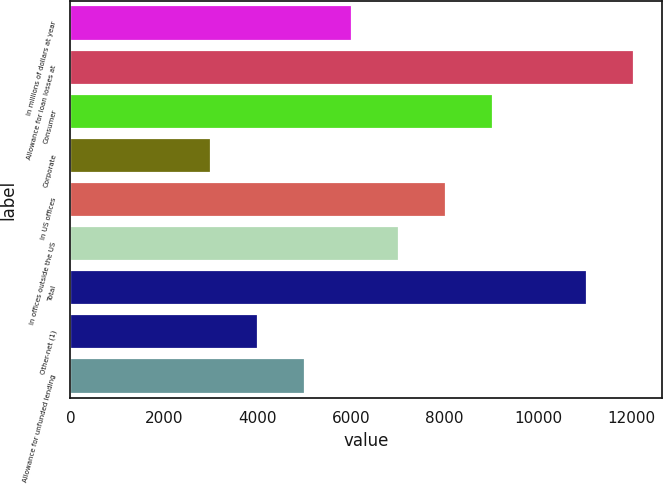<chart> <loc_0><loc_0><loc_500><loc_500><bar_chart><fcel>In millions of dollars at year<fcel>Allowance for loan losses at<fcel>Consumer<fcel>Corporate<fcel>In US offices<fcel>In offices outside the US<fcel>Total<fcel>Other-net (1)<fcel>Allowance for unfunded lending<nl><fcel>6024.05<fcel>12048<fcel>9036.05<fcel>3012.05<fcel>8032.05<fcel>7028.05<fcel>11044<fcel>4016.05<fcel>5020.05<nl></chart> 